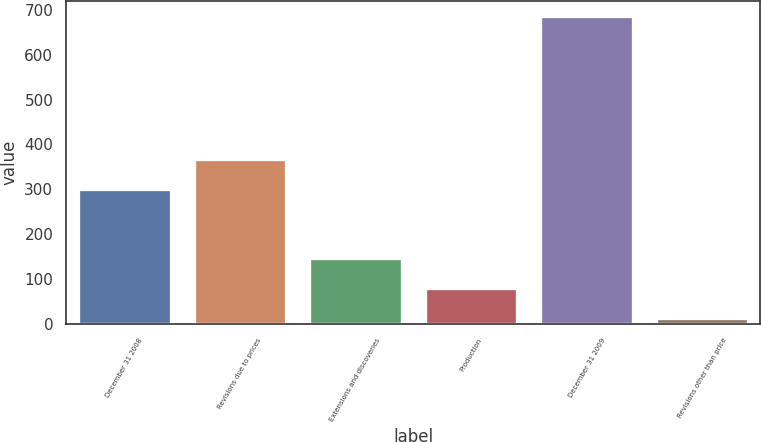Convert chart. <chart><loc_0><loc_0><loc_500><loc_500><bar_chart><fcel>December 31 2008<fcel>Revisions due to prices<fcel>Extensions and discoveries<fcel>Production<fcel>December 31 2009<fcel>Revisions other than price<nl><fcel>301<fcel>368.3<fcel>147.6<fcel>80.3<fcel>686<fcel>13<nl></chart> 